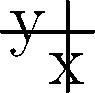In a TV ratings graph, three episodes of "Zach Stone Is Gonna Be Famous" are represented by points A(-2, 4), B(1, 1), and C(3, 9) on a coordinate plane. Find the equation of the parabola that passes through these three points, where the x-axis represents the episode number and the y-axis represents the ratings (in millions of viewers). To find the equation of the parabola passing through these three points, we'll use the general form of a quadratic equation: $y = ax^2 + bx + c$

Step 1: Substitute the coordinates of each point into the general equation:
For A(-2, 4): $4 = 4a - 2b + c$
For B(1, 1):  $1 = a + b + c$
For C(3, 9):  $9 = 9a + 3b + c$

Step 2: Subtract the equation for B from the equations for A and C:
A - B: $3 = 3a - 3b$
C - B: $8 = 8a + 2b$

Step 3: Solve for b in terms of a using the first equation:
$3 = 3a - 3b$
$b = a - 1$

Step 4: Substitute this expression for b into the second equation:
$8 = 8a + 2(a - 1)$
$8 = 8a + 2a - 2$
$10 = 10a$
$a = 1$

Step 5: Find b by substituting a = 1 into the equation from Step 3:
$b = 1 - 1 = 0$

Step 6: Use the equation for point B to find c:
$1 = 1 + 0 + c$
$c = 0$

Step 7: Write the final equation of the parabola:
$y = x^2 + 0x + 0$
$y = x^2$
Answer: $y = x^2$ 